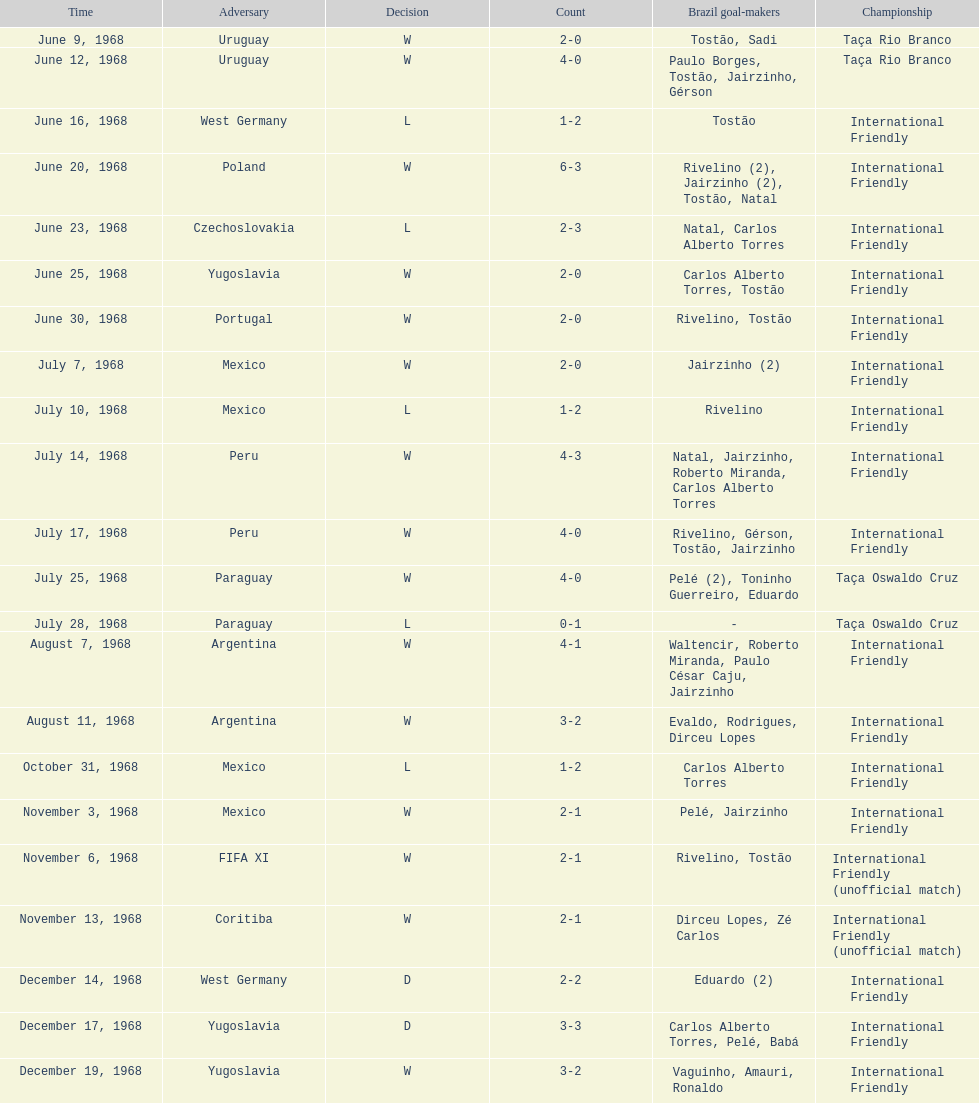How many times did brazil score during the game on november 6th? 2. 